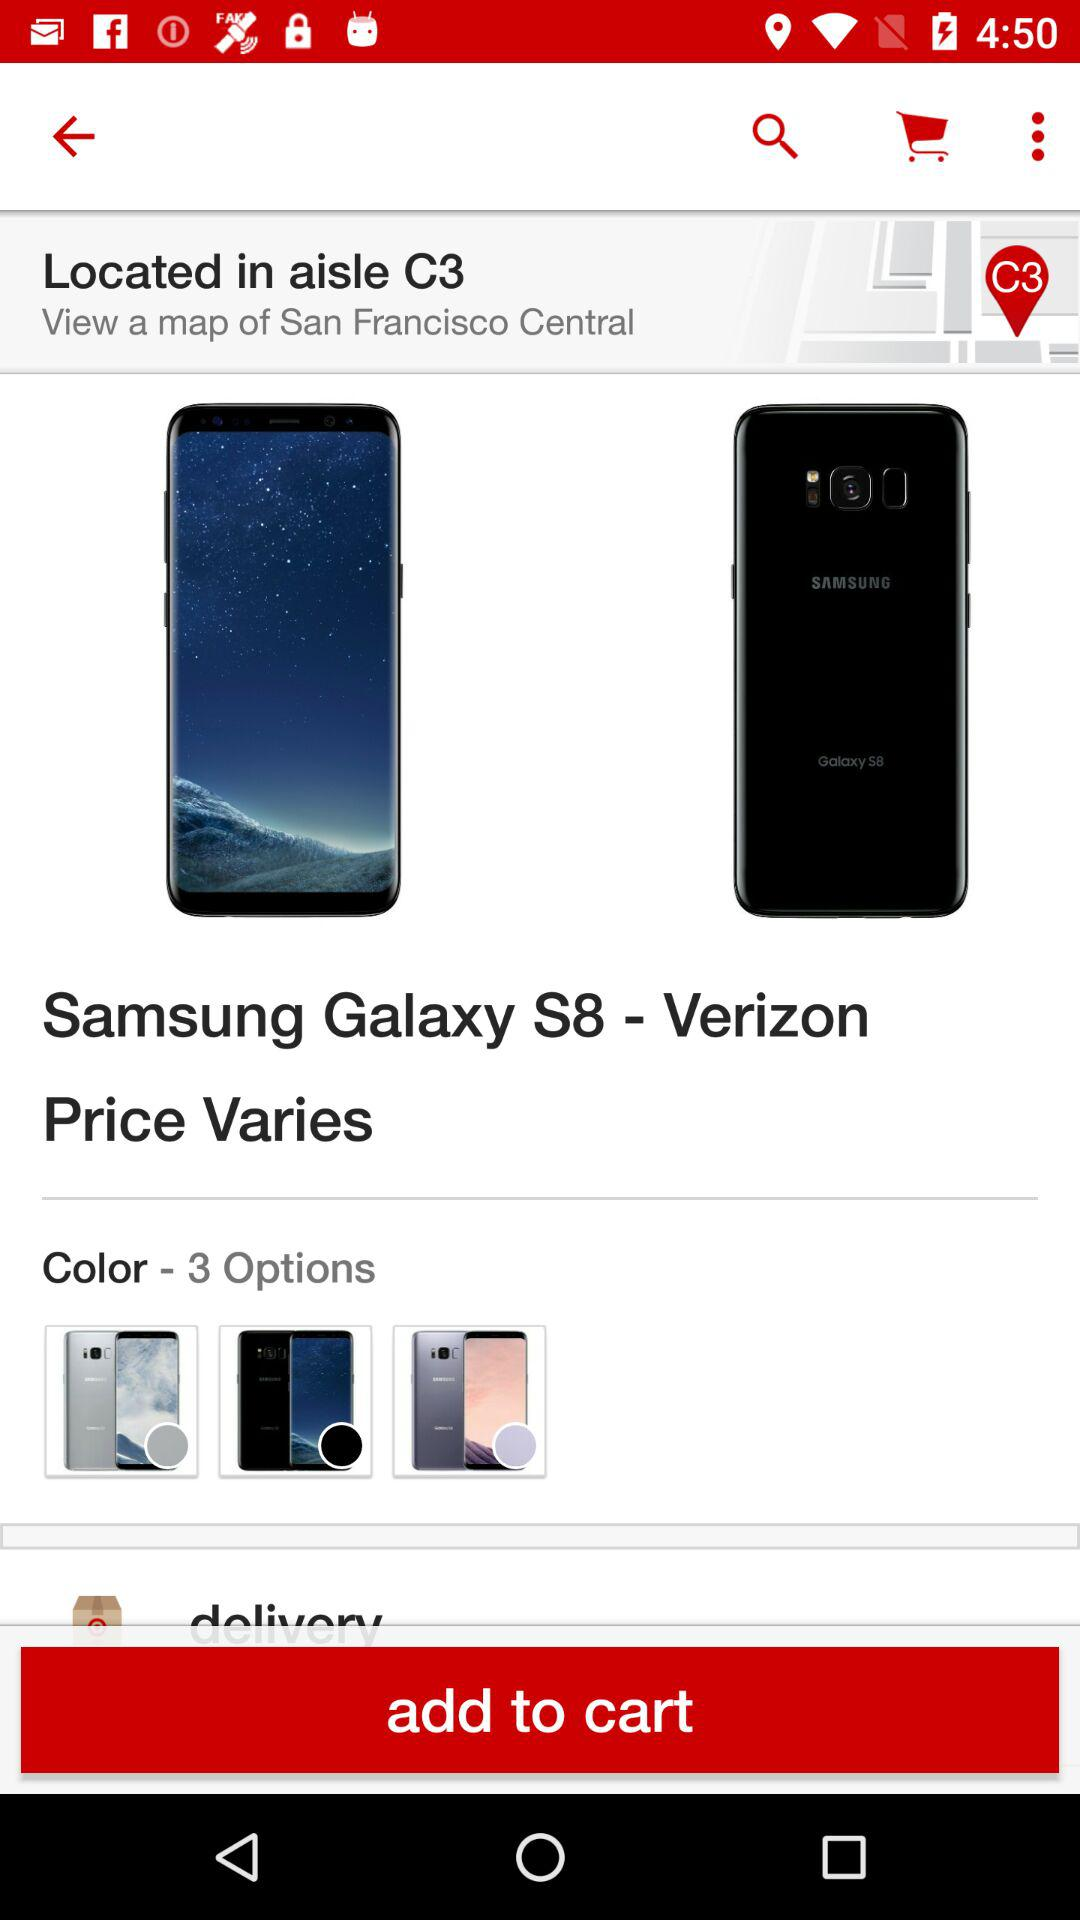What is the location? The location is San Francisco Central. 